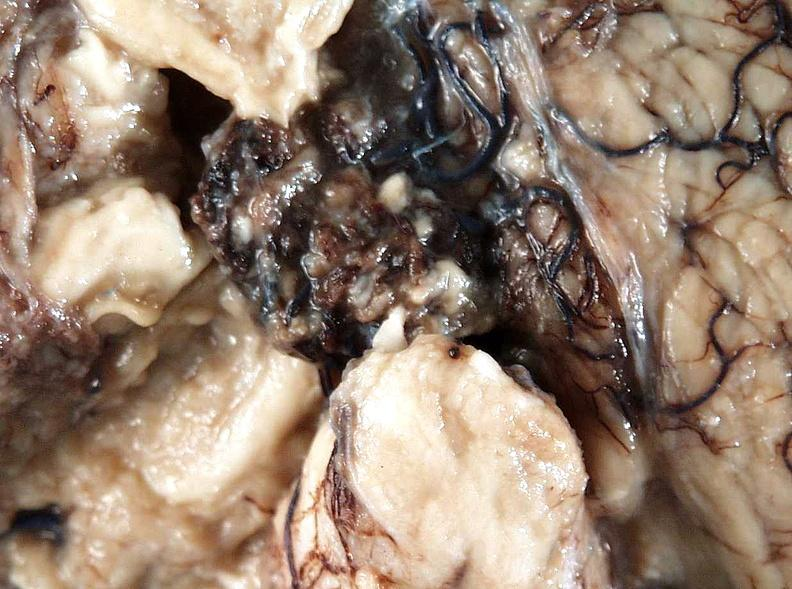s optic nerve present?
Answer the question using a single word or phrase. No 